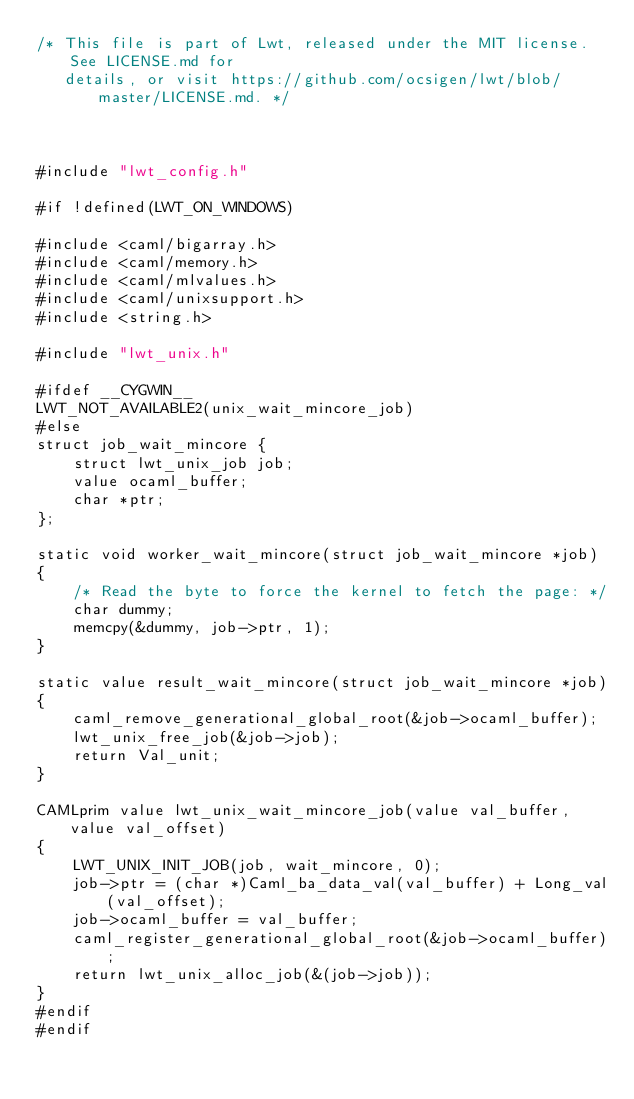<code> <loc_0><loc_0><loc_500><loc_500><_C_>/* This file is part of Lwt, released under the MIT license. See LICENSE.md for
   details, or visit https://github.com/ocsigen/lwt/blob/master/LICENSE.md. */



#include "lwt_config.h"

#if !defined(LWT_ON_WINDOWS)

#include <caml/bigarray.h>
#include <caml/memory.h>
#include <caml/mlvalues.h>
#include <caml/unixsupport.h>
#include <string.h>

#include "lwt_unix.h"

#ifdef __CYGWIN__
LWT_NOT_AVAILABLE2(unix_wait_mincore_job)
#else
struct job_wait_mincore {
    struct lwt_unix_job job;
    value ocaml_buffer;
    char *ptr;
};

static void worker_wait_mincore(struct job_wait_mincore *job)
{
    /* Read the byte to force the kernel to fetch the page: */
    char dummy;
    memcpy(&dummy, job->ptr, 1);
}

static value result_wait_mincore(struct job_wait_mincore *job)
{
    caml_remove_generational_global_root(&job->ocaml_buffer);
    lwt_unix_free_job(&job->job);
    return Val_unit;
}

CAMLprim value lwt_unix_wait_mincore_job(value val_buffer, value val_offset)
{
    LWT_UNIX_INIT_JOB(job, wait_mincore, 0);
    job->ptr = (char *)Caml_ba_data_val(val_buffer) + Long_val(val_offset);
    job->ocaml_buffer = val_buffer;
    caml_register_generational_global_root(&job->ocaml_buffer);
    return lwt_unix_alloc_job(&(job->job));
}
#endif
#endif
</code> 